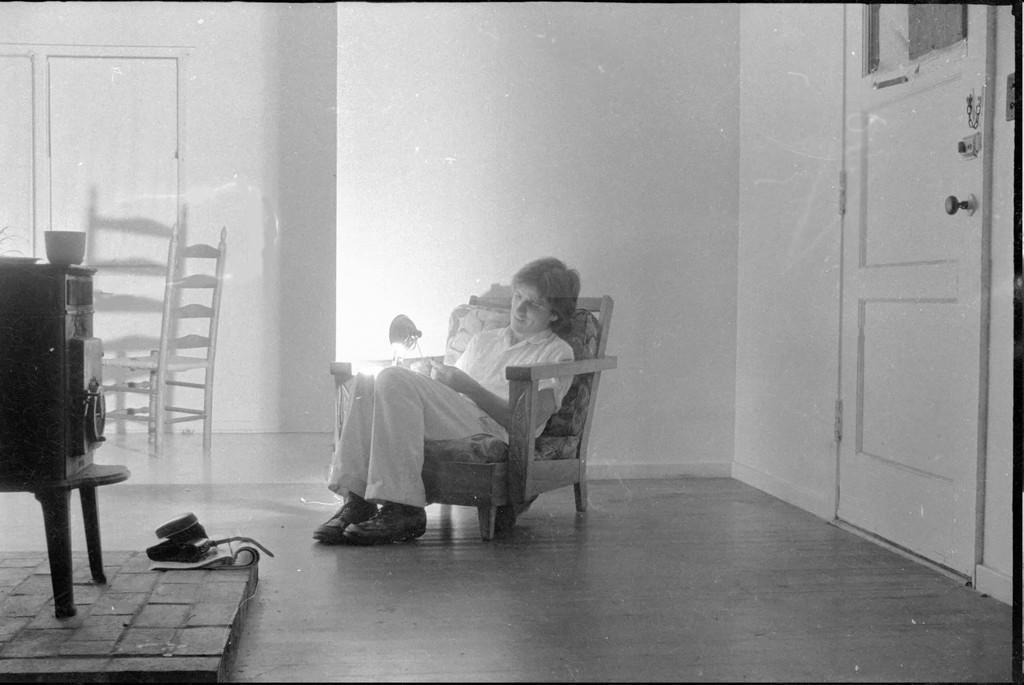In one or two sentences, can you explain what this image depicts? In this image in the center there is a man sitting on a sofa having smile on his face. On the left side is an object which is black in colour on the stool, and there is an empty chair. On the right side there is a door which is white in colour. 